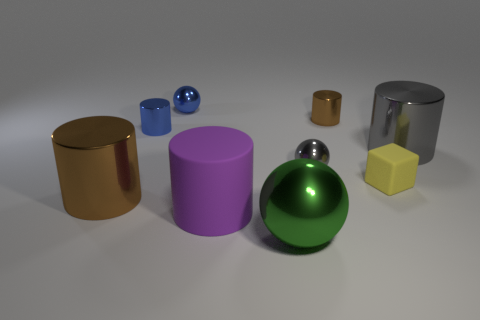What is the size of the rubber object that is left of the brown cylinder behind the large gray cylinder?
Give a very brief answer. Large. Is the color of the big rubber object the same as the big object behind the tiny gray thing?
Provide a succinct answer. No. What is the material of the blue cylinder that is the same size as the blue metallic ball?
Ensure brevity in your answer.  Metal. Are there fewer blue metal balls in front of the blue ball than tiny yellow matte objects that are on the right side of the tiny gray object?
Provide a succinct answer. Yes. The tiny object that is behind the brown object that is right of the tiny blue shiny cylinder is what shape?
Your answer should be compact. Sphere. Is there a tiny gray object?
Your answer should be very brief. Yes. What color is the tiny ball that is on the left side of the purple matte thing?
Provide a short and direct response. Blue. Are there any blue spheres in front of the big brown cylinder?
Keep it short and to the point. No. Is the number of red matte spheres greater than the number of gray cylinders?
Your answer should be compact. No. What is the color of the shiny object behind the small shiny cylinder that is to the right of the gray metal thing that is in front of the large gray cylinder?
Ensure brevity in your answer.  Blue. 